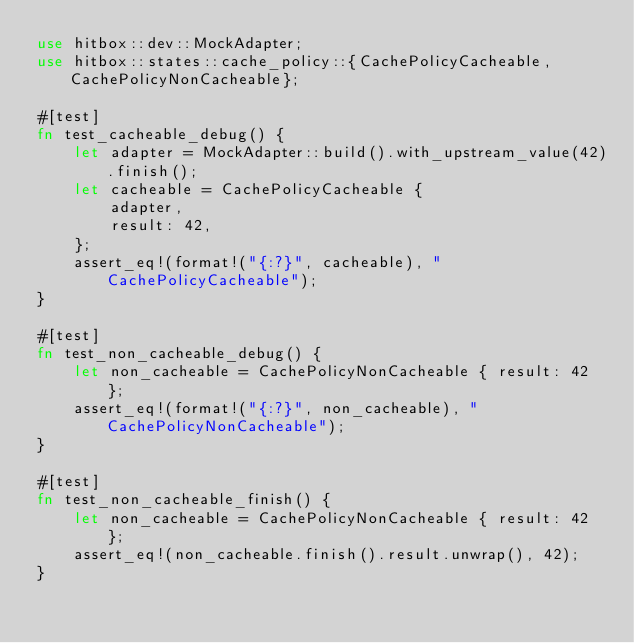Convert code to text. <code><loc_0><loc_0><loc_500><loc_500><_Rust_>use hitbox::dev::MockAdapter;
use hitbox::states::cache_policy::{CachePolicyCacheable, CachePolicyNonCacheable};

#[test]
fn test_cacheable_debug() {
    let adapter = MockAdapter::build().with_upstream_value(42).finish();
    let cacheable = CachePolicyCacheable {
        adapter,
        result: 42,
    };
    assert_eq!(format!("{:?}", cacheable), "CachePolicyCacheable");
}

#[test]
fn test_non_cacheable_debug() {
    let non_cacheable = CachePolicyNonCacheable { result: 42 };
    assert_eq!(format!("{:?}", non_cacheable), "CachePolicyNonCacheable");
}

#[test]
fn test_non_cacheable_finish() {
    let non_cacheable = CachePolicyNonCacheable { result: 42 };
    assert_eq!(non_cacheable.finish().result.unwrap(), 42);
}
</code> 